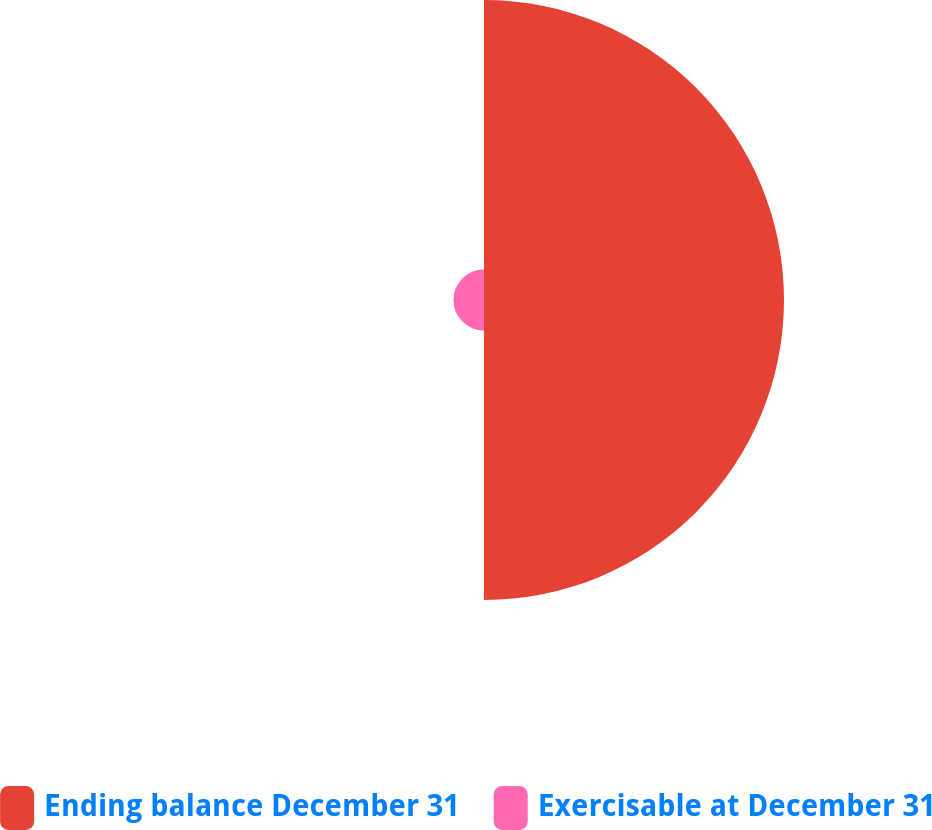Convert chart to OTSL. <chart><loc_0><loc_0><loc_500><loc_500><pie_chart><fcel>Ending balance December 31<fcel>Exercisable at December 31<nl><fcel>90.76%<fcel>9.24%<nl></chart> 